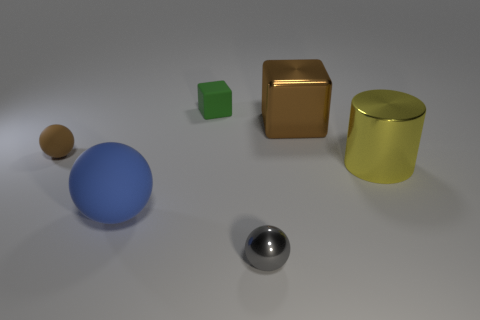Is the number of things that are on the right side of the tiny metallic sphere less than the number of tiny brown blocks?
Keep it short and to the point. No. There is a tiny object to the left of the green block; is its color the same as the big matte ball?
Your answer should be compact. No. How many rubber things are either large cylinders or purple cubes?
Your answer should be compact. 0. Are there any other things that have the same size as the metal cylinder?
Offer a very short reply. Yes. The small ball that is the same material as the large block is what color?
Give a very brief answer. Gray. How many spheres are yellow things or big blue matte objects?
Your answer should be very brief. 1. What number of objects are rubber cubes or things behind the yellow thing?
Offer a terse response. 3. Is there a blue rubber sphere?
Make the answer very short. Yes. What number of tiny metal objects have the same color as the cylinder?
Your response must be concise. 0. What is the material of the tiny object that is the same color as the shiny block?
Make the answer very short. Rubber. 